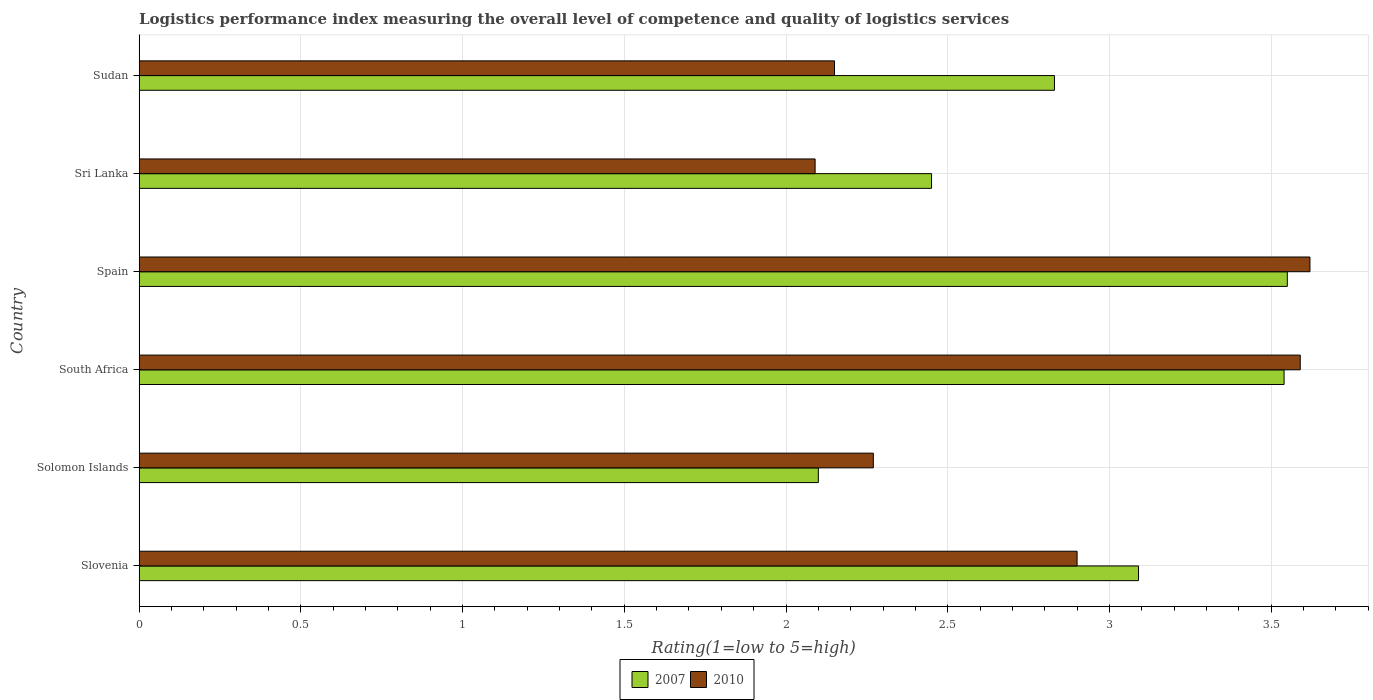How many groups of bars are there?
Your answer should be very brief. 6. Are the number of bars per tick equal to the number of legend labels?
Keep it short and to the point. Yes. Are the number of bars on each tick of the Y-axis equal?
Ensure brevity in your answer.  Yes. How many bars are there on the 3rd tick from the top?
Offer a terse response. 2. How many bars are there on the 6th tick from the bottom?
Give a very brief answer. 2. What is the label of the 3rd group of bars from the top?
Keep it short and to the point. Spain. In how many cases, is the number of bars for a given country not equal to the number of legend labels?
Offer a very short reply. 0. What is the Logistic performance index in 2010 in Sri Lanka?
Offer a terse response. 2.09. Across all countries, what is the maximum Logistic performance index in 2007?
Your answer should be compact. 3.55. In which country was the Logistic performance index in 2007 maximum?
Your answer should be very brief. Spain. In which country was the Logistic performance index in 2007 minimum?
Offer a very short reply. Solomon Islands. What is the total Logistic performance index in 2010 in the graph?
Your answer should be very brief. 16.62. What is the difference between the Logistic performance index in 2010 in Slovenia and that in Sudan?
Your response must be concise. 0.75. What is the difference between the Logistic performance index in 2007 in South Africa and the Logistic performance index in 2010 in Sri Lanka?
Keep it short and to the point. 1.45. What is the average Logistic performance index in 2007 per country?
Give a very brief answer. 2.93. What is the difference between the Logistic performance index in 2010 and Logistic performance index in 2007 in South Africa?
Your response must be concise. 0.05. What is the ratio of the Logistic performance index in 2007 in Slovenia to that in Sudan?
Your answer should be compact. 1.09. What is the difference between the highest and the second highest Logistic performance index in 2007?
Your response must be concise. 0.01. What is the difference between the highest and the lowest Logistic performance index in 2010?
Provide a succinct answer. 1.53. In how many countries, is the Logistic performance index in 2007 greater than the average Logistic performance index in 2007 taken over all countries?
Make the answer very short. 3. What does the 1st bar from the bottom in Sri Lanka represents?
Ensure brevity in your answer.  2007. How many bars are there?
Your answer should be very brief. 12. How many countries are there in the graph?
Offer a very short reply. 6. Does the graph contain any zero values?
Provide a short and direct response. No. Does the graph contain grids?
Provide a succinct answer. Yes. Where does the legend appear in the graph?
Ensure brevity in your answer.  Bottom center. How many legend labels are there?
Your response must be concise. 2. How are the legend labels stacked?
Offer a very short reply. Horizontal. What is the title of the graph?
Offer a very short reply. Logistics performance index measuring the overall level of competence and quality of logistics services. What is the label or title of the X-axis?
Your answer should be very brief. Rating(1=low to 5=high). What is the Rating(1=low to 5=high) in 2007 in Slovenia?
Keep it short and to the point. 3.09. What is the Rating(1=low to 5=high) of 2010 in Slovenia?
Ensure brevity in your answer.  2.9. What is the Rating(1=low to 5=high) in 2010 in Solomon Islands?
Offer a terse response. 2.27. What is the Rating(1=low to 5=high) in 2007 in South Africa?
Give a very brief answer. 3.54. What is the Rating(1=low to 5=high) in 2010 in South Africa?
Your answer should be very brief. 3.59. What is the Rating(1=low to 5=high) in 2007 in Spain?
Keep it short and to the point. 3.55. What is the Rating(1=low to 5=high) in 2010 in Spain?
Give a very brief answer. 3.62. What is the Rating(1=low to 5=high) in 2007 in Sri Lanka?
Provide a short and direct response. 2.45. What is the Rating(1=low to 5=high) in 2010 in Sri Lanka?
Keep it short and to the point. 2.09. What is the Rating(1=low to 5=high) of 2007 in Sudan?
Keep it short and to the point. 2.83. What is the Rating(1=low to 5=high) in 2010 in Sudan?
Make the answer very short. 2.15. Across all countries, what is the maximum Rating(1=low to 5=high) in 2007?
Your answer should be compact. 3.55. Across all countries, what is the maximum Rating(1=low to 5=high) in 2010?
Your answer should be very brief. 3.62. Across all countries, what is the minimum Rating(1=low to 5=high) of 2007?
Make the answer very short. 2.1. Across all countries, what is the minimum Rating(1=low to 5=high) in 2010?
Offer a very short reply. 2.09. What is the total Rating(1=low to 5=high) in 2007 in the graph?
Your answer should be very brief. 17.56. What is the total Rating(1=low to 5=high) in 2010 in the graph?
Offer a very short reply. 16.62. What is the difference between the Rating(1=low to 5=high) of 2010 in Slovenia and that in Solomon Islands?
Give a very brief answer. 0.63. What is the difference between the Rating(1=low to 5=high) of 2007 in Slovenia and that in South Africa?
Offer a terse response. -0.45. What is the difference between the Rating(1=low to 5=high) in 2010 in Slovenia and that in South Africa?
Your response must be concise. -0.69. What is the difference between the Rating(1=low to 5=high) in 2007 in Slovenia and that in Spain?
Offer a very short reply. -0.46. What is the difference between the Rating(1=low to 5=high) in 2010 in Slovenia and that in Spain?
Provide a short and direct response. -0.72. What is the difference between the Rating(1=low to 5=high) of 2007 in Slovenia and that in Sri Lanka?
Make the answer very short. 0.64. What is the difference between the Rating(1=low to 5=high) in 2010 in Slovenia and that in Sri Lanka?
Make the answer very short. 0.81. What is the difference between the Rating(1=low to 5=high) of 2007 in Slovenia and that in Sudan?
Provide a succinct answer. 0.26. What is the difference between the Rating(1=low to 5=high) of 2007 in Solomon Islands and that in South Africa?
Ensure brevity in your answer.  -1.44. What is the difference between the Rating(1=low to 5=high) in 2010 in Solomon Islands and that in South Africa?
Your response must be concise. -1.32. What is the difference between the Rating(1=low to 5=high) in 2007 in Solomon Islands and that in Spain?
Ensure brevity in your answer.  -1.45. What is the difference between the Rating(1=low to 5=high) of 2010 in Solomon Islands and that in Spain?
Make the answer very short. -1.35. What is the difference between the Rating(1=low to 5=high) of 2007 in Solomon Islands and that in Sri Lanka?
Make the answer very short. -0.35. What is the difference between the Rating(1=low to 5=high) in 2010 in Solomon Islands and that in Sri Lanka?
Provide a short and direct response. 0.18. What is the difference between the Rating(1=low to 5=high) in 2007 in Solomon Islands and that in Sudan?
Provide a short and direct response. -0.73. What is the difference between the Rating(1=low to 5=high) of 2010 in Solomon Islands and that in Sudan?
Make the answer very short. 0.12. What is the difference between the Rating(1=low to 5=high) of 2007 in South Africa and that in Spain?
Give a very brief answer. -0.01. What is the difference between the Rating(1=low to 5=high) in 2010 in South Africa and that in Spain?
Ensure brevity in your answer.  -0.03. What is the difference between the Rating(1=low to 5=high) in 2007 in South Africa and that in Sri Lanka?
Provide a short and direct response. 1.09. What is the difference between the Rating(1=low to 5=high) of 2007 in South Africa and that in Sudan?
Give a very brief answer. 0.71. What is the difference between the Rating(1=low to 5=high) in 2010 in South Africa and that in Sudan?
Your answer should be very brief. 1.44. What is the difference between the Rating(1=low to 5=high) in 2007 in Spain and that in Sri Lanka?
Your response must be concise. 1.1. What is the difference between the Rating(1=low to 5=high) of 2010 in Spain and that in Sri Lanka?
Give a very brief answer. 1.53. What is the difference between the Rating(1=low to 5=high) of 2007 in Spain and that in Sudan?
Your response must be concise. 0.72. What is the difference between the Rating(1=low to 5=high) in 2010 in Spain and that in Sudan?
Keep it short and to the point. 1.47. What is the difference between the Rating(1=low to 5=high) in 2007 in Sri Lanka and that in Sudan?
Ensure brevity in your answer.  -0.38. What is the difference between the Rating(1=low to 5=high) in 2010 in Sri Lanka and that in Sudan?
Give a very brief answer. -0.06. What is the difference between the Rating(1=low to 5=high) in 2007 in Slovenia and the Rating(1=low to 5=high) in 2010 in Solomon Islands?
Your response must be concise. 0.82. What is the difference between the Rating(1=low to 5=high) in 2007 in Slovenia and the Rating(1=low to 5=high) in 2010 in South Africa?
Your answer should be compact. -0.5. What is the difference between the Rating(1=low to 5=high) of 2007 in Slovenia and the Rating(1=low to 5=high) of 2010 in Spain?
Offer a very short reply. -0.53. What is the difference between the Rating(1=low to 5=high) in 2007 in Solomon Islands and the Rating(1=low to 5=high) in 2010 in South Africa?
Provide a short and direct response. -1.49. What is the difference between the Rating(1=low to 5=high) in 2007 in Solomon Islands and the Rating(1=low to 5=high) in 2010 in Spain?
Ensure brevity in your answer.  -1.52. What is the difference between the Rating(1=low to 5=high) in 2007 in South Africa and the Rating(1=low to 5=high) in 2010 in Spain?
Offer a terse response. -0.08. What is the difference between the Rating(1=low to 5=high) of 2007 in South Africa and the Rating(1=low to 5=high) of 2010 in Sri Lanka?
Your answer should be compact. 1.45. What is the difference between the Rating(1=low to 5=high) in 2007 in South Africa and the Rating(1=low to 5=high) in 2010 in Sudan?
Ensure brevity in your answer.  1.39. What is the difference between the Rating(1=low to 5=high) in 2007 in Spain and the Rating(1=low to 5=high) in 2010 in Sri Lanka?
Your answer should be very brief. 1.46. What is the difference between the Rating(1=low to 5=high) in 2007 in Spain and the Rating(1=low to 5=high) in 2010 in Sudan?
Your response must be concise. 1.4. What is the difference between the Rating(1=low to 5=high) in 2007 in Sri Lanka and the Rating(1=low to 5=high) in 2010 in Sudan?
Keep it short and to the point. 0.3. What is the average Rating(1=low to 5=high) of 2007 per country?
Your answer should be very brief. 2.93. What is the average Rating(1=low to 5=high) of 2010 per country?
Keep it short and to the point. 2.77. What is the difference between the Rating(1=low to 5=high) in 2007 and Rating(1=low to 5=high) in 2010 in Slovenia?
Offer a terse response. 0.19. What is the difference between the Rating(1=low to 5=high) of 2007 and Rating(1=low to 5=high) of 2010 in Solomon Islands?
Ensure brevity in your answer.  -0.17. What is the difference between the Rating(1=low to 5=high) of 2007 and Rating(1=low to 5=high) of 2010 in South Africa?
Provide a short and direct response. -0.05. What is the difference between the Rating(1=low to 5=high) of 2007 and Rating(1=low to 5=high) of 2010 in Spain?
Your response must be concise. -0.07. What is the difference between the Rating(1=low to 5=high) of 2007 and Rating(1=low to 5=high) of 2010 in Sri Lanka?
Give a very brief answer. 0.36. What is the difference between the Rating(1=low to 5=high) of 2007 and Rating(1=low to 5=high) of 2010 in Sudan?
Keep it short and to the point. 0.68. What is the ratio of the Rating(1=low to 5=high) in 2007 in Slovenia to that in Solomon Islands?
Your response must be concise. 1.47. What is the ratio of the Rating(1=low to 5=high) in 2010 in Slovenia to that in Solomon Islands?
Provide a succinct answer. 1.28. What is the ratio of the Rating(1=low to 5=high) in 2007 in Slovenia to that in South Africa?
Your answer should be very brief. 0.87. What is the ratio of the Rating(1=low to 5=high) of 2010 in Slovenia to that in South Africa?
Offer a very short reply. 0.81. What is the ratio of the Rating(1=low to 5=high) of 2007 in Slovenia to that in Spain?
Provide a short and direct response. 0.87. What is the ratio of the Rating(1=low to 5=high) in 2010 in Slovenia to that in Spain?
Give a very brief answer. 0.8. What is the ratio of the Rating(1=low to 5=high) in 2007 in Slovenia to that in Sri Lanka?
Give a very brief answer. 1.26. What is the ratio of the Rating(1=low to 5=high) of 2010 in Slovenia to that in Sri Lanka?
Your response must be concise. 1.39. What is the ratio of the Rating(1=low to 5=high) of 2007 in Slovenia to that in Sudan?
Your response must be concise. 1.09. What is the ratio of the Rating(1=low to 5=high) in 2010 in Slovenia to that in Sudan?
Keep it short and to the point. 1.35. What is the ratio of the Rating(1=low to 5=high) of 2007 in Solomon Islands to that in South Africa?
Provide a short and direct response. 0.59. What is the ratio of the Rating(1=low to 5=high) in 2010 in Solomon Islands to that in South Africa?
Give a very brief answer. 0.63. What is the ratio of the Rating(1=low to 5=high) of 2007 in Solomon Islands to that in Spain?
Give a very brief answer. 0.59. What is the ratio of the Rating(1=low to 5=high) in 2010 in Solomon Islands to that in Spain?
Keep it short and to the point. 0.63. What is the ratio of the Rating(1=low to 5=high) of 2007 in Solomon Islands to that in Sri Lanka?
Ensure brevity in your answer.  0.86. What is the ratio of the Rating(1=low to 5=high) of 2010 in Solomon Islands to that in Sri Lanka?
Your answer should be very brief. 1.09. What is the ratio of the Rating(1=low to 5=high) in 2007 in Solomon Islands to that in Sudan?
Make the answer very short. 0.74. What is the ratio of the Rating(1=low to 5=high) of 2010 in Solomon Islands to that in Sudan?
Your answer should be very brief. 1.06. What is the ratio of the Rating(1=low to 5=high) in 2007 in South Africa to that in Spain?
Your answer should be compact. 1. What is the ratio of the Rating(1=low to 5=high) in 2010 in South Africa to that in Spain?
Offer a terse response. 0.99. What is the ratio of the Rating(1=low to 5=high) in 2007 in South Africa to that in Sri Lanka?
Offer a very short reply. 1.44. What is the ratio of the Rating(1=low to 5=high) of 2010 in South Africa to that in Sri Lanka?
Offer a terse response. 1.72. What is the ratio of the Rating(1=low to 5=high) in 2007 in South Africa to that in Sudan?
Ensure brevity in your answer.  1.25. What is the ratio of the Rating(1=low to 5=high) in 2010 in South Africa to that in Sudan?
Keep it short and to the point. 1.67. What is the ratio of the Rating(1=low to 5=high) in 2007 in Spain to that in Sri Lanka?
Keep it short and to the point. 1.45. What is the ratio of the Rating(1=low to 5=high) in 2010 in Spain to that in Sri Lanka?
Make the answer very short. 1.73. What is the ratio of the Rating(1=low to 5=high) of 2007 in Spain to that in Sudan?
Your response must be concise. 1.25. What is the ratio of the Rating(1=low to 5=high) in 2010 in Spain to that in Sudan?
Your response must be concise. 1.68. What is the ratio of the Rating(1=low to 5=high) in 2007 in Sri Lanka to that in Sudan?
Keep it short and to the point. 0.87. What is the ratio of the Rating(1=low to 5=high) of 2010 in Sri Lanka to that in Sudan?
Your answer should be compact. 0.97. What is the difference between the highest and the second highest Rating(1=low to 5=high) in 2007?
Your response must be concise. 0.01. What is the difference between the highest and the lowest Rating(1=low to 5=high) of 2007?
Provide a succinct answer. 1.45. What is the difference between the highest and the lowest Rating(1=low to 5=high) of 2010?
Offer a very short reply. 1.53. 